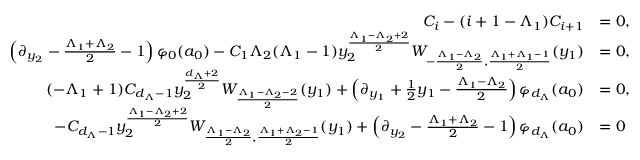<formula> <loc_0><loc_0><loc_500><loc_500>\begin{array} { r l } { C _ { i } - ( i + 1 - \Lambda _ { 1 } ) C _ { i + 1 } } & { = 0 , } \\ { \left ( \partial _ { y _ { 2 } } - \frac { \Lambda _ { 1 } + \Lambda _ { 2 } } { 2 } - 1 \right ) \varphi _ { 0 } ( a _ { 0 } ) - C _ { 1 } \Lambda _ { 2 } ( \Lambda _ { 1 } - 1 ) y _ { 2 } ^ { \frac { \Lambda _ { 1 } - \Lambda _ { 2 } + 2 } { 2 } } W _ { - \frac { \Lambda _ { 1 } - \Lambda _ { 2 } } { 2 } , \frac { \Lambda _ { 1 } + \Lambda _ { 1 } - 1 } { 2 } } ( y _ { 1 } ) } & { = 0 , } \\ { ( - \Lambda _ { 1 } + 1 ) C _ { d _ { \Lambda } - 1 } y _ { 2 } ^ { \frac { d _ { \Lambda } + 2 } { 2 } } W _ { \frac { \Lambda _ { 1 } - \Lambda _ { 2 } - 2 } { 2 } } ( y _ { 1 } ) + \left ( \partial _ { y _ { 1 } } + \frac { 1 } { 2 } y _ { 1 } - \frac { \Lambda _ { 1 } - \Lambda _ { 2 } } { 2 } \right ) \varphi _ { d _ { \Lambda } } ( a _ { 0 } ) } & { = 0 , } \\ { - C _ { d _ { \Lambda } - 1 } y _ { 2 } ^ { \frac { \Lambda _ { 1 } - \Lambda _ { 2 } + 2 } { 2 } } W _ { \frac { \Lambda _ { 1 } - \Lambda _ { 2 } } { 2 } , \frac { \Lambda _ { 1 } + \Lambda _ { 2 } - 1 } { 2 } } ( y _ { 1 } ) + \left ( \partial _ { y _ { 2 } } - \frac { \Lambda _ { 1 } + \Lambda _ { 2 } } { 2 } - 1 \right ) \varphi _ { d _ { \Lambda } } ( a _ { 0 } ) } & { = 0 } \end{array}</formula> 